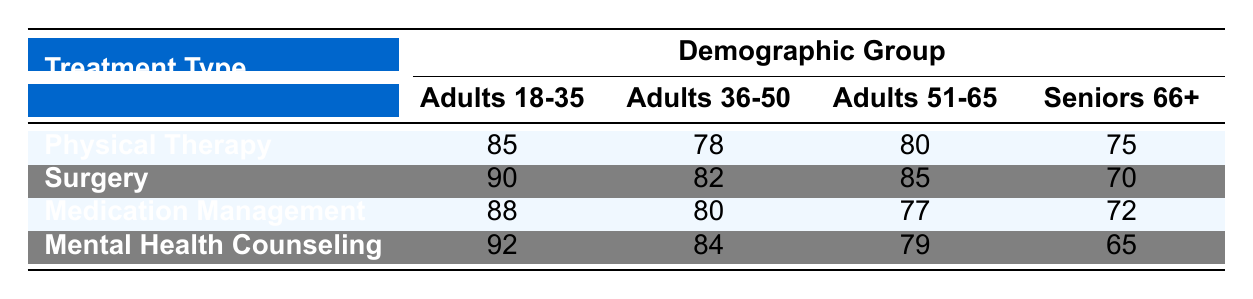What is the satisfaction score for Surgery among Seniors 66+? The table shows that the satisfaction score for the treatment type "Surgery" in the demographic group "Seniors 66+" is 70.
Answer: 70 What is the highest satisfaction score recorded in the table? By examining the table values, the highest satisfaction score is found for "Mental Health Counseling" among "Adults 18-35," which is 92.
Answer: 92 What is the average satisfaction score for Adults 36-50 across all treatment types? To find the average, we must first add the satisfaction scores for Adults 36-50: 78 (Physical Therapy) + 82 (Surgery) + 80 (Medication Management) + 84 (Mental Health Counseling) = 324. Then divide by the number of treatments, which is 4. So, 324/4 = 81.
Answer: 81 Is the satisfaction score for Physical Therapy among Adults 51-65 greater than that of Medication Management among Seniors 66+? According to the table, Physical Therapy for Adults 51-65 has a score of 80, and Medication Management for Seniors 66+ has a score of 72. Since 80 is greater than 72, the statement is true.
Answer: Yes What is the difference in satisfaction scores between Adults 18-35 for Mental Health Counseling and Surgery? First, we find the scores: Mental Health Counseling for Adults 18-35 is 92, and Surgery for Adults 18-35 is 90. The difference is calculated as 92 - 90 = 2.
Answer: 2 Which treatment type has the lowest satisfaction score overall? By comparing all the satisfaction scores, we observe that the lowest score belongs to "Mental Health Counseling" for "Seniors 66+", which is 65.
Answer: Mental Health Counseling What is the satisfaction score for Medication Management among Adults 51-65? The table indicates that the satisfaction score for "Medication Management" in the "Adults 51-65" group is 77.
Answer: 77 Which demographic group has the highest satisfaction score for Physical Therapy? According to the table, "Adults 18-35" has the highest score for Physical Therapy, which is 85.
Answer: Adults 18-35 What is the total satisfaction score for Surgery for all demographic groups combined? We need to add the satisfaction scores for Surgery across all demographic groups: 90 (Adults 18-35) + 82 (Adults 36-50) + 85 (Adults 51-65) + 70 (Seniors 66+) = 327.
Answer: 327 